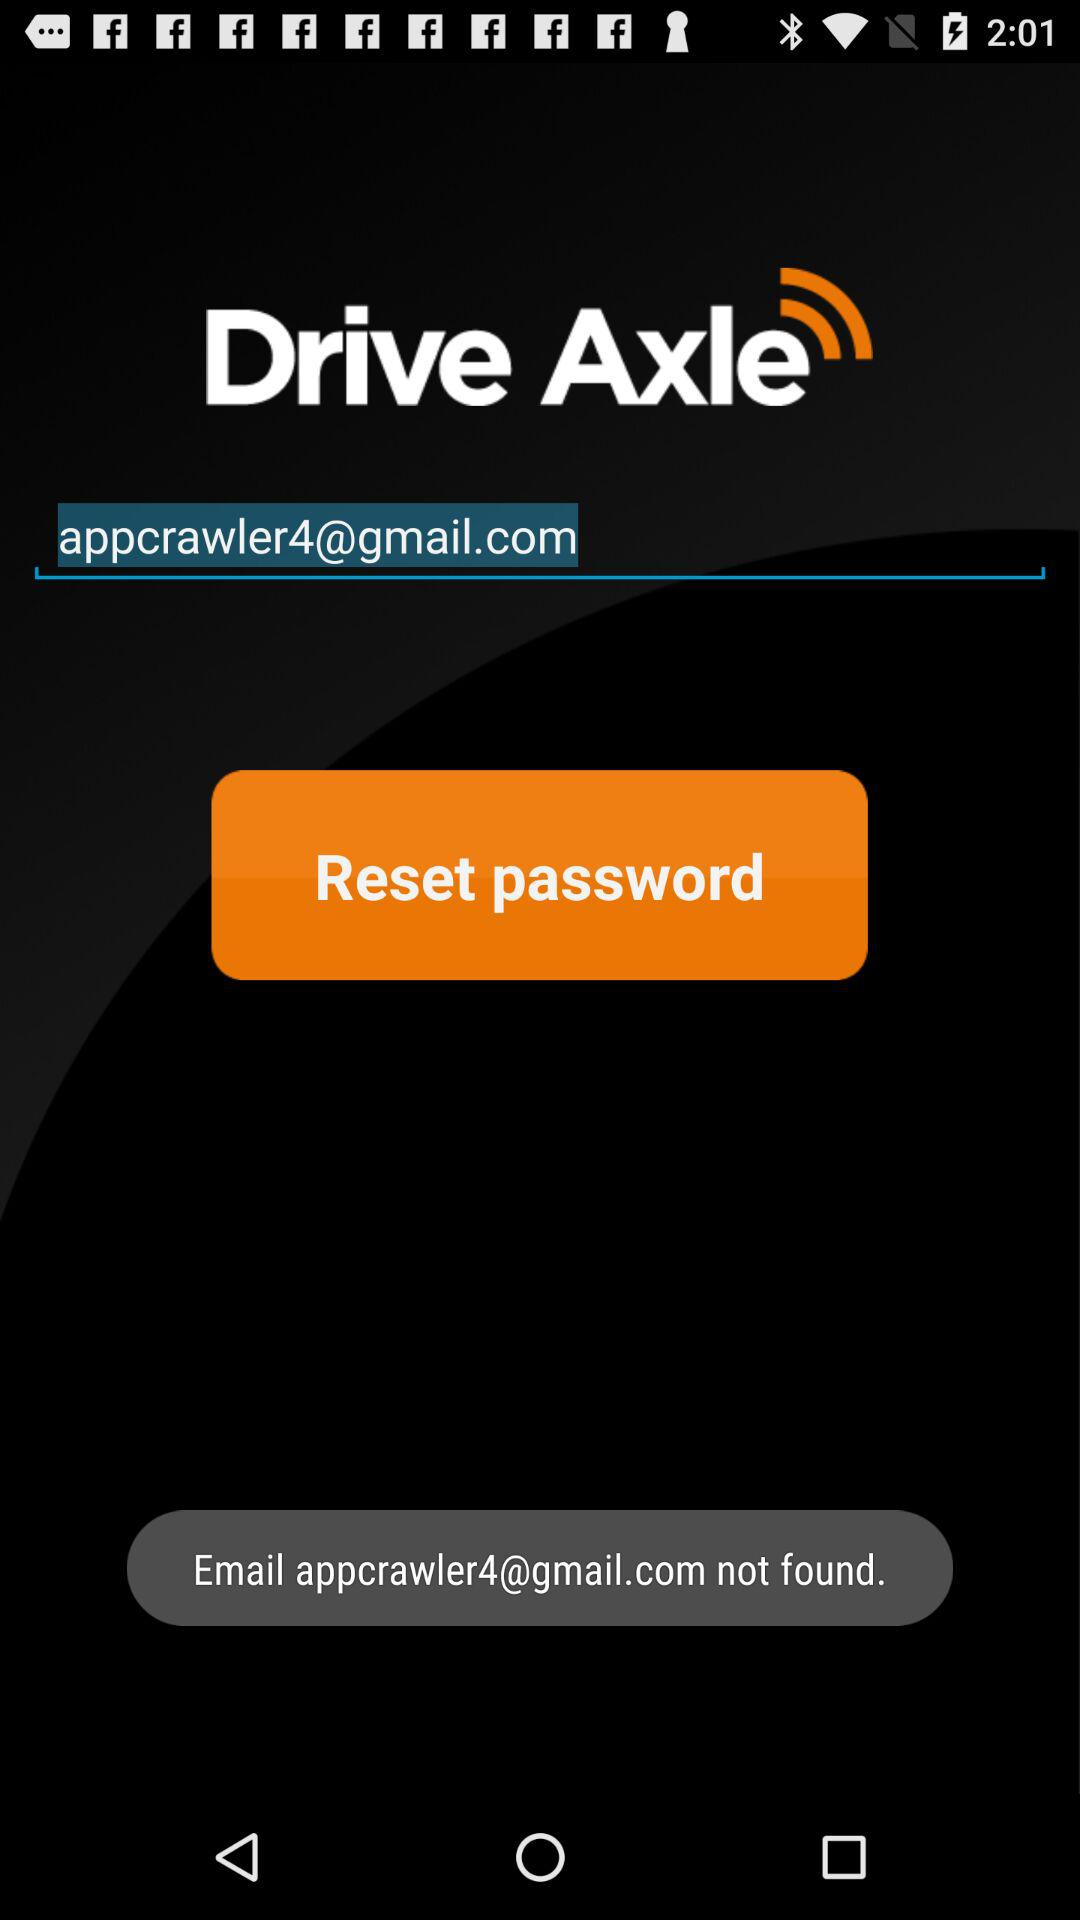How many text input fields are there on this screen?
Answer the question using a single word or phrase. 2 